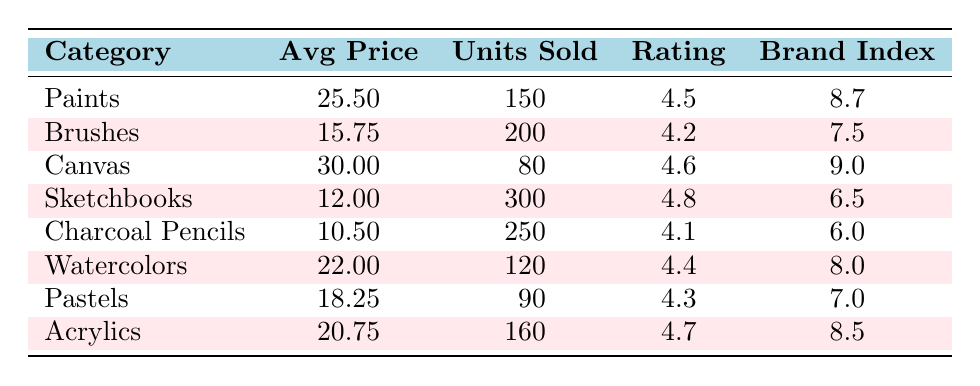What is the average price of Brushes? The table lists the average price of Brushes as 15.75. There is no need for further calculations.
Answer: 15.75 Which category has the highest customer rating? By comparing the customer ratings across categories, Sketchbooks has the highest rating at 4.8.
Answer: Sketchbooks What is the total number of units sold for Paints and Acrylics combined? Paints sold 150 units and Acrylics sold 160 units. Summing these gives 150 + 160 = 310.
Answer: 310 Is the brand recognition index for Canvas higher than that of Pastels? The brand recognition index for Canvas is 9.0 while for Pastels it is 7.0. Since 9.0 is greater than 7.0, the statement is true.
Answer: Yes What percentage of units sold for Sketchbooks does Charcoal Pencils account for? Sketchbooks sold 300 units, and Charcoal Pencils sold 250 units. To find the percentage, (250 / 300) * 100 = 83.33%.
Answer: 83.33% Which category sells more units: Watercolors or Pastels? Watercolors sold 120 units, while Pastels sold 90 units. Comparing these values shows that Watercolors sold more units than Pastels.
Answer: Watercolors What is the average customer rating for all categories combined? The customer ratings need to be summed: 4.5 + 4.2 + 4.6 + 4.8 + 4.1 + 4.4 + 4.3 + 4.7 = 34.6. Dividing by the number of categories (8) gives 34.6 / 8 = 4.325.
Answer: 4.325 Do more units sold correlate positively with higher average prices in this dataset? Looking at the data, categories like Sketchbooks and Charcoal Pencils sell the most units (300 and 250 respectively) but have lower prices compared to Paints and Canvas. This might indicate a negative correlation between units sold and average prices.
Answer: No 